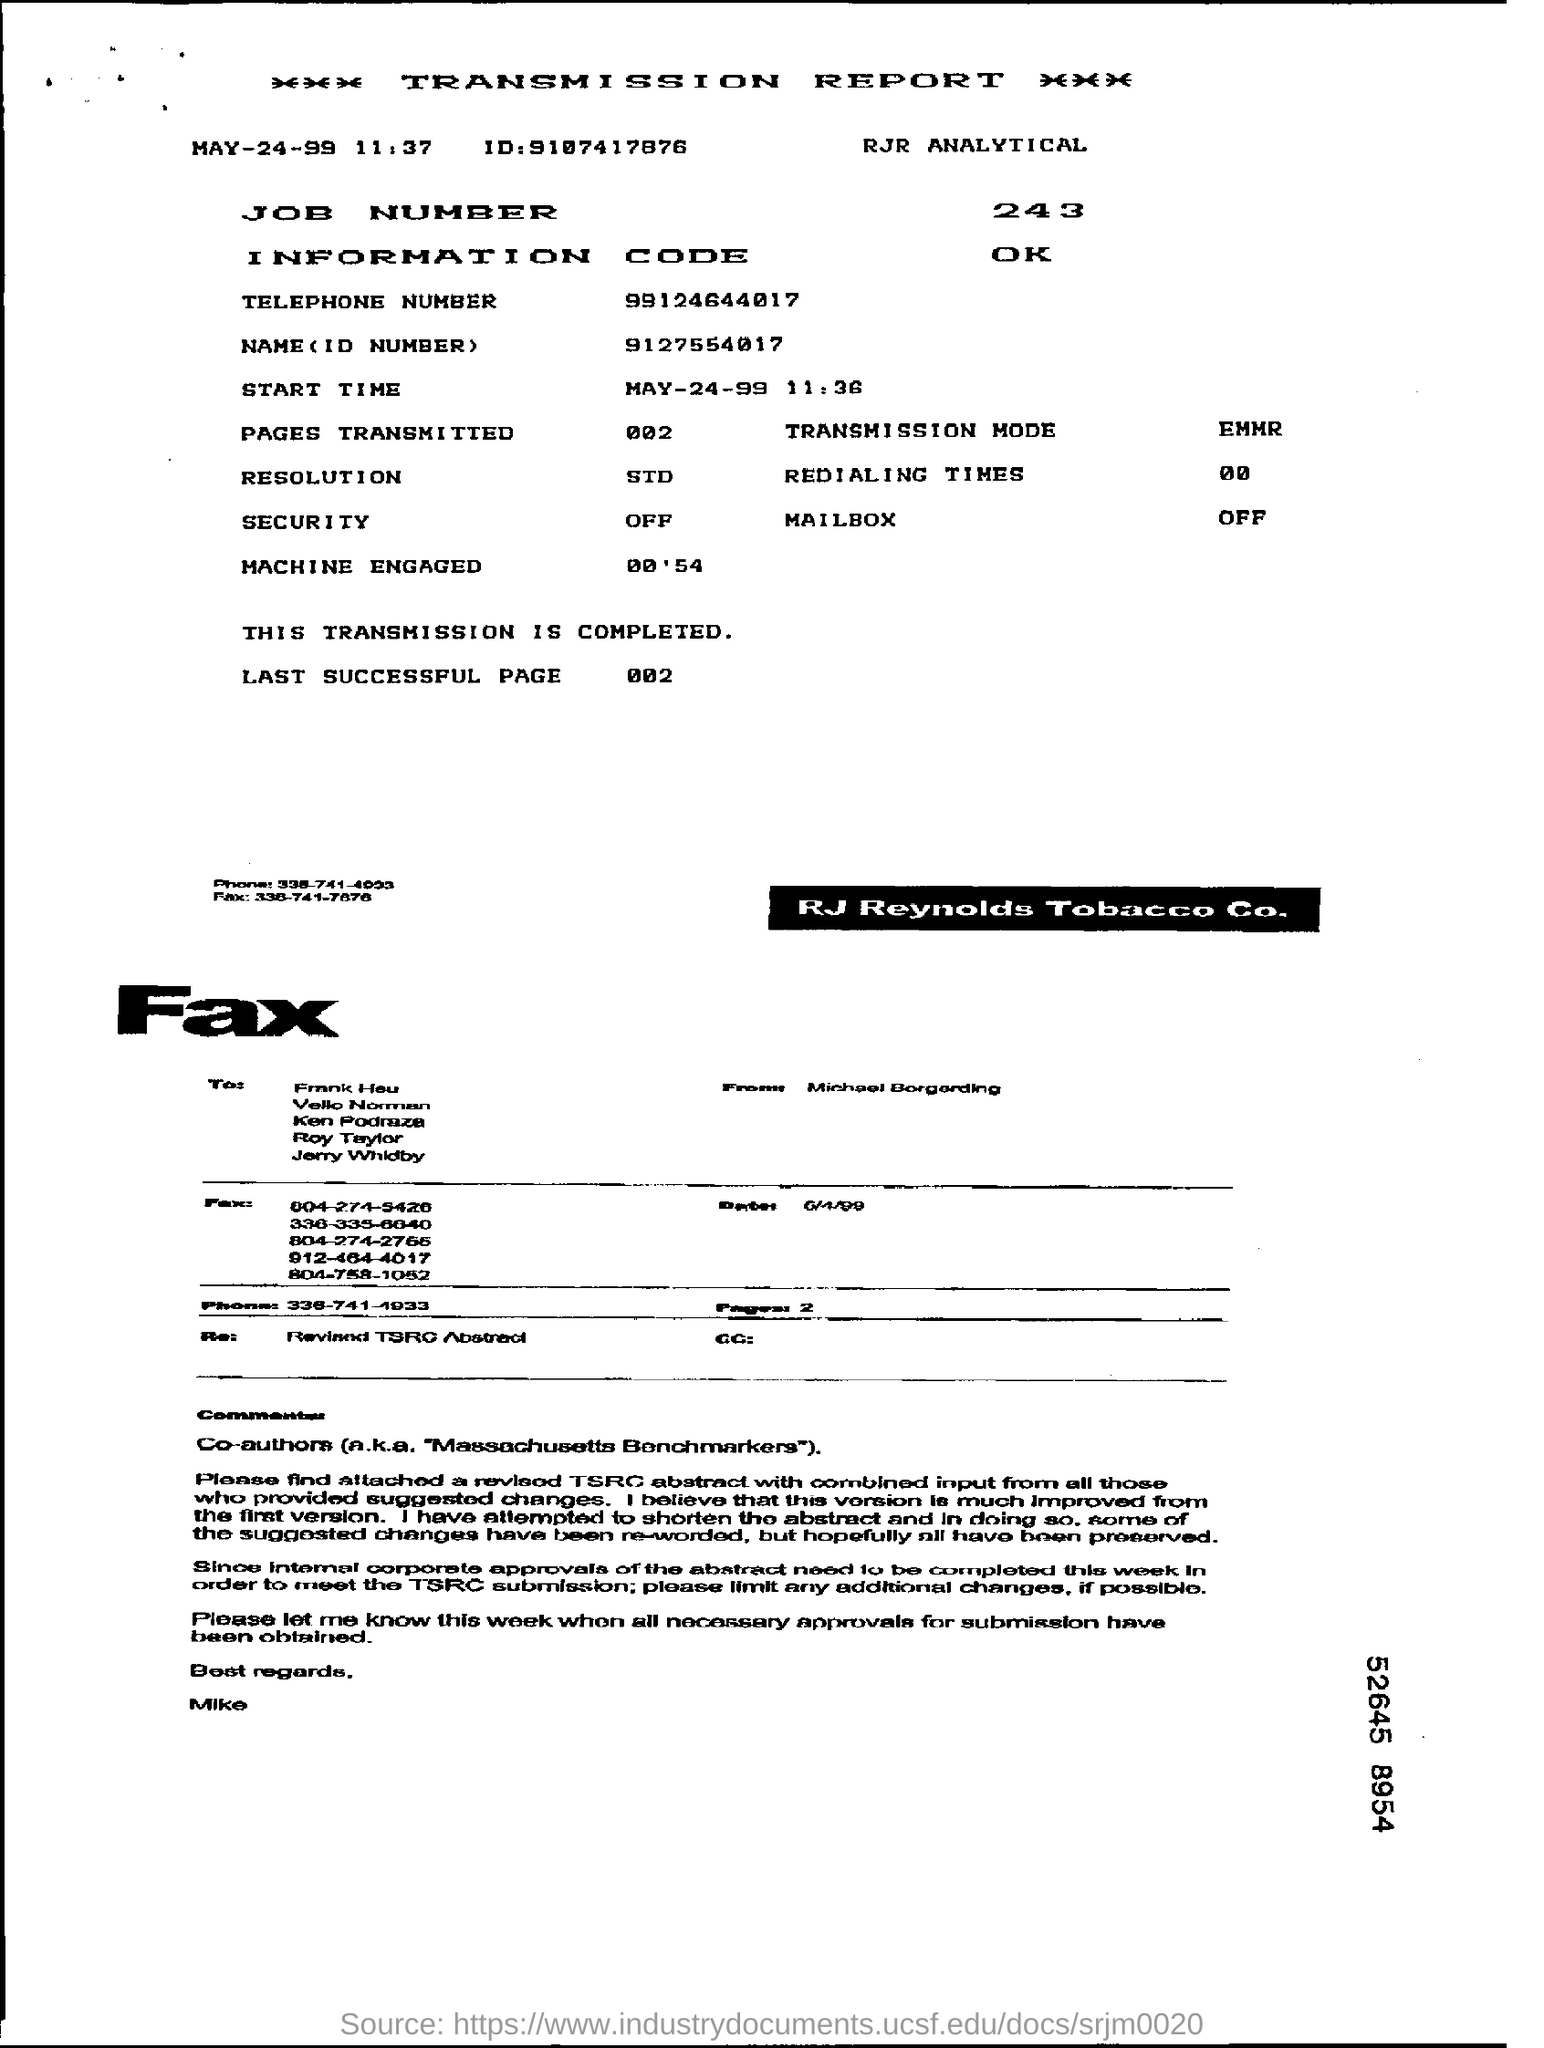What is the ID mentioned?
Your answer should be compact. 9107417876. What is the telephone number mentioned?
Offer a very short reply. 99124644017. 